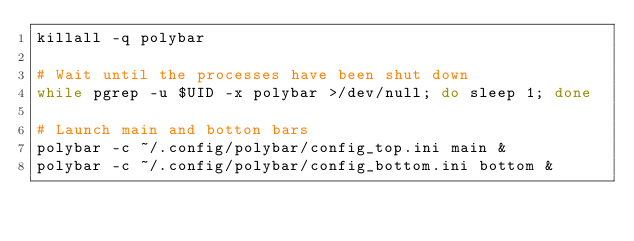Convert code to text. <code><loc_0><loc_0><loc_500><loc_500><_Bash_>killall -q polybar

# Wait until the processes have been shut down
while pgrep -u $UID -x polybar >/dev/null; do sleep 1; done

# Launch main and botton bars
polybar -c ~/.config/polybar/config_top.ini main &
polybar -c ~/.config/polybar/config_bottom.ini bottom &
</code> 